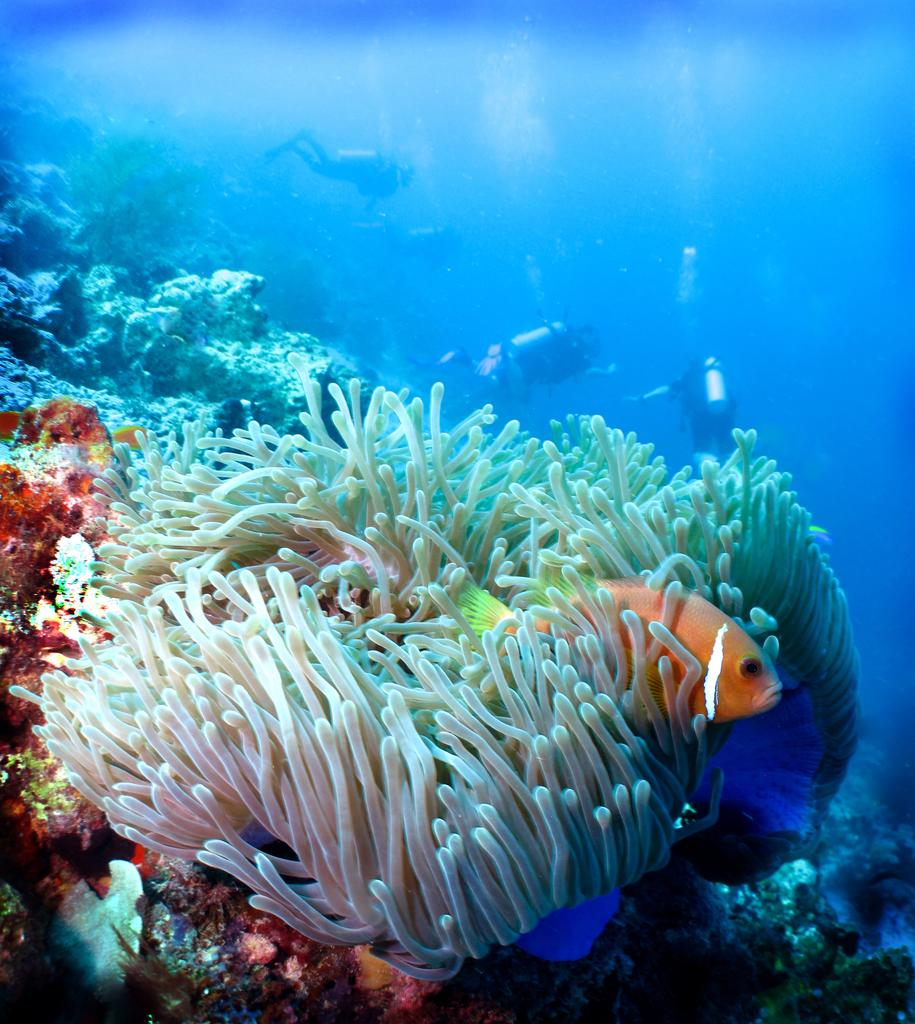What type of environment is shown in the image? The image depicts an underwater scene. Can you describe one of the fish in the image? There is a gold and white fish in the image. What other aquatic animals can be seen in the image? There are other aquatic animals in the image. Who is present in the image besides the aquatic animals? There are people in the image. What color is the water in the image? The water is blue in color. What type of mint can be seen growing underwater in the image? There is no mint visible in the image; it is an underwater scene, plants like mint are not present. 